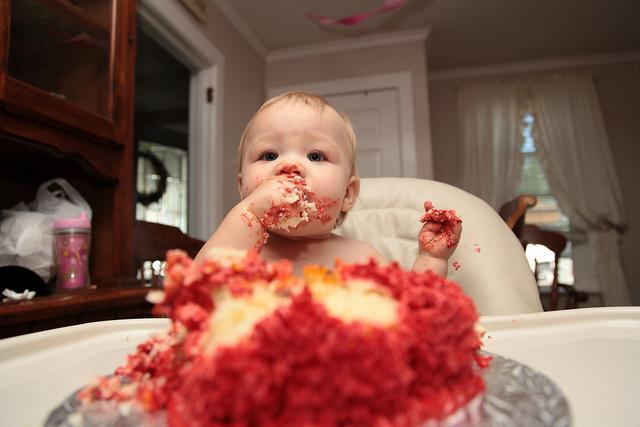What's the baby done to get so messy?
Choose the correct response, then elucidate: 'Answer: answer
Rationale: rationale.'
Options: Found dirt, opened jar, ate food, painted picture. Answer: ate food.
Rationale: The baby stuck her hands in the cake in front of her and has smeared cake and frosting all over her face. 